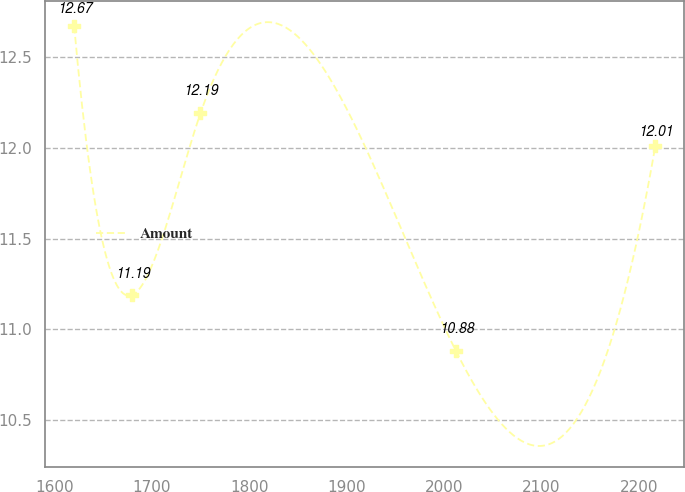Convert chart to OTSL. <chart><loc_0><loc_0><loc_500><loc_500><line_chart><ecel><fcel>Amount<nl><fcel>1620.15<fcel>12.67<nl><fcel>1679.81<fcel>11.19<nl><fcel>1749.76<fcel>12.19<nl><fcel>2012.22<fcel>10.88<nl><fcel>2216.77<fcel>12.01<nl></chart> 